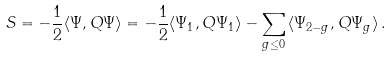<formula> <loc_0><loc_0><loc_500><loc_500>S = - \frac { 1 } { 2 } \langle \Psi , Q \Psi \rangle = - \frac { 1 } { 2 } \langle \Psi _ { 1 } , Q \Psi _ { 1 } \rangle - \sum _ { g \leq 0 } \, \langle \Psi _ { 2 - g } , Q \Psi _ { g } \rangle \, .</formula> 